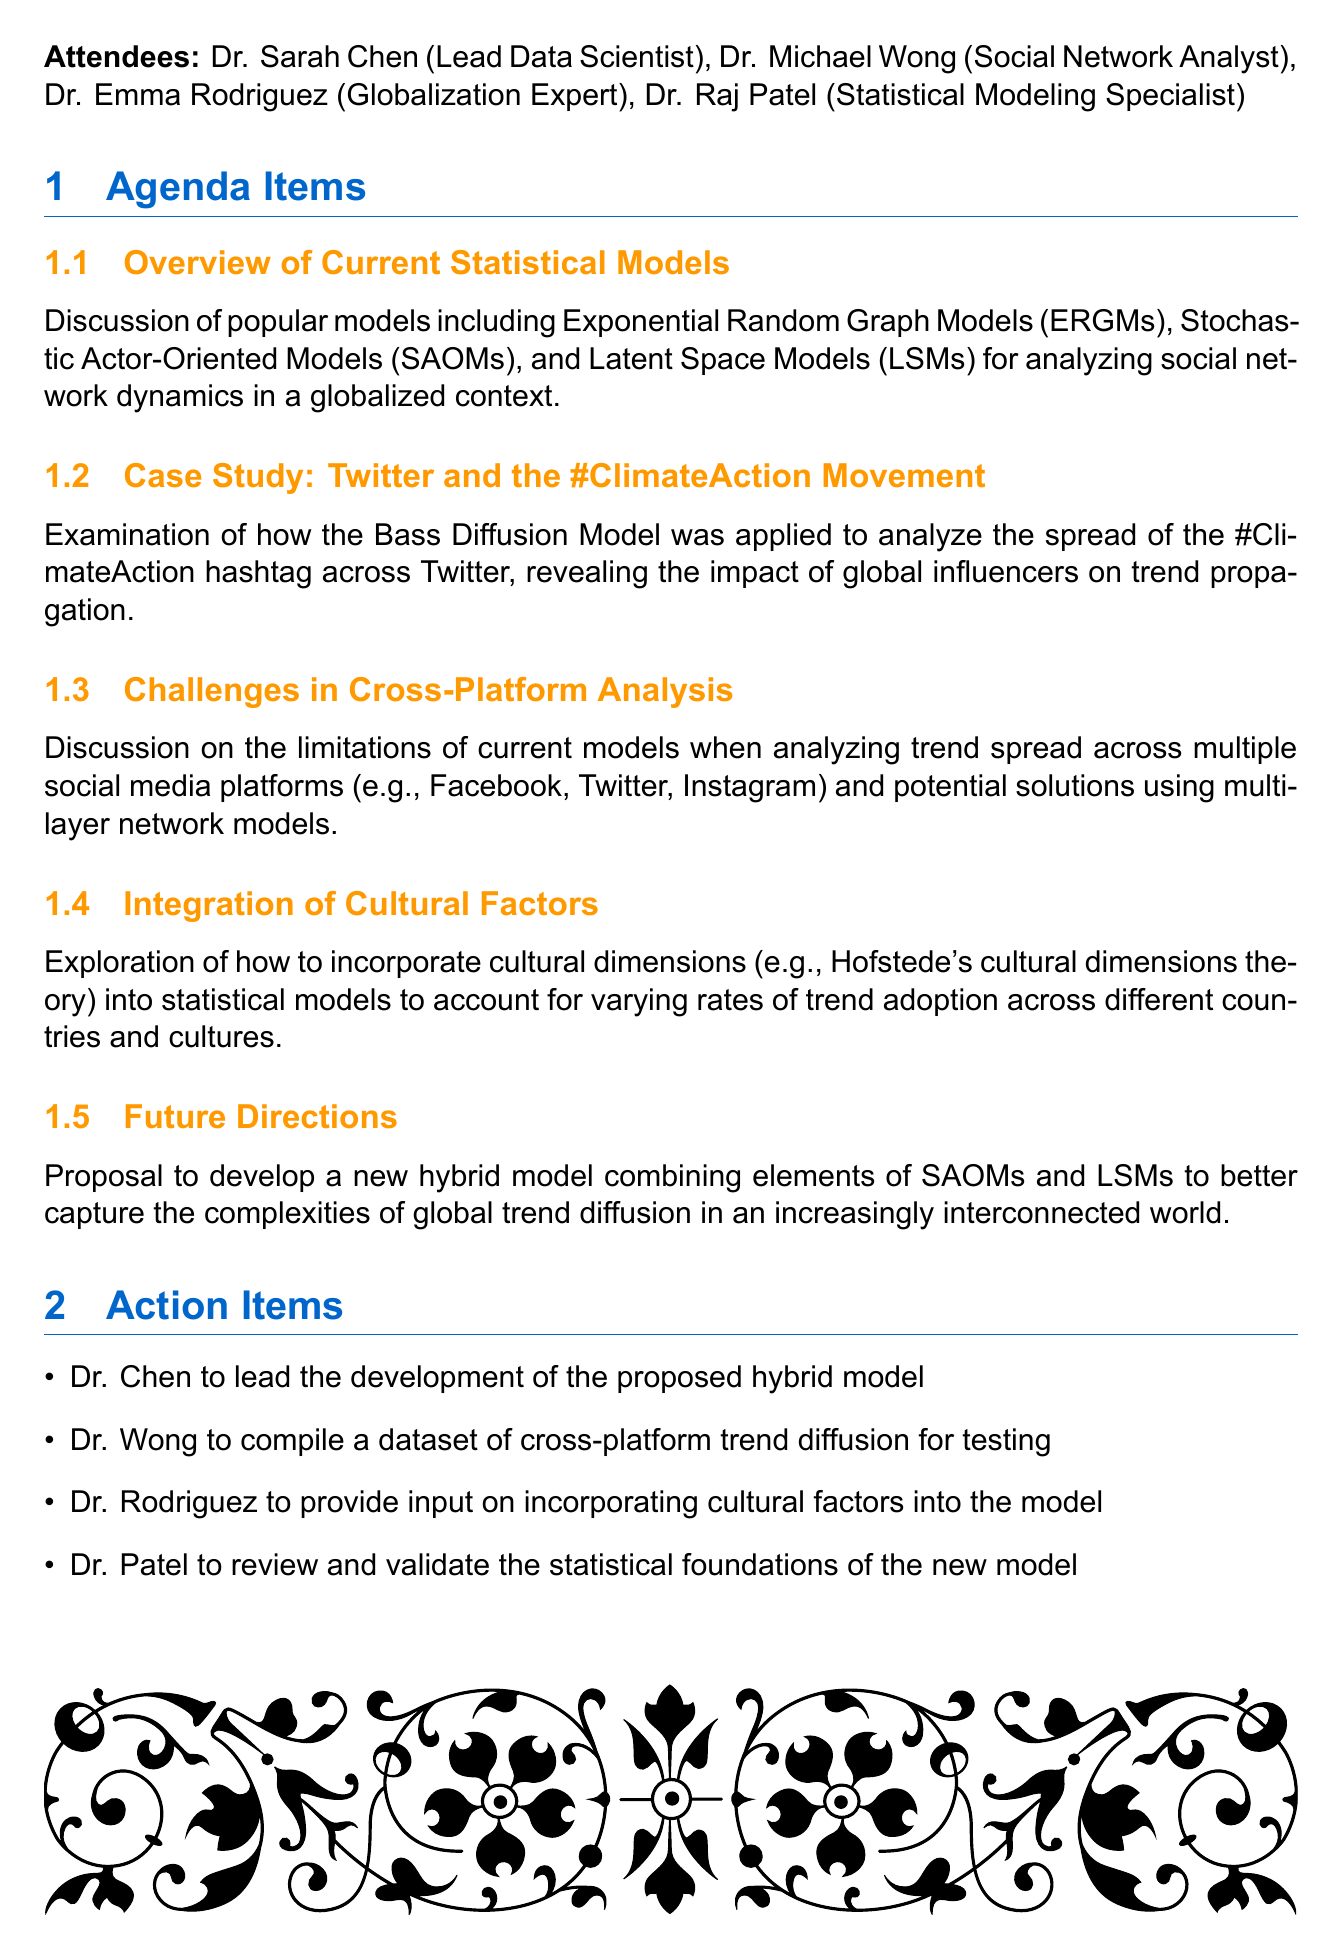What is the meeting title? The meeting title is prominently listed at the beginning of the document.
Answer: Review of Statistical Models for Analyzing Global Trend Spread on Social Media Who is the lead data scientist? The document lists attendees with their roles, identifying the lead data scientist.
Answer: Dr. Sarah Chen What date was the meeting held? The date of the meeting is mentioned at the start of the document.
Answer: May 15, 2023 What model was discussed in relation to the #ClimateAction hashtag? The specific model applied to analyze the spread of the hashtag is included in the case study section.
Answer: Bass Diffusion Model What are the proposed solutions for cross-platform analysis? The document discusses potential solutions within the Challenges in Cross-Platform Analysis agenda item.
Answer: Multi-layer network models Who is tasked with compiling a dataset for testing? The action items specify who will undertake each task after the meeting.
Answer: Dr. Wong What is the next meeting date? The date of the next meeting is provided at the end of the document.
Answer: June 1, 2023 Which cultural theory was mentioned for model integration? The section on cultural factors references a specific theory for incorporation into statistical models.
Answer: Hofstede's cultural dimensions theory How many attendees were present at the meeting? The attendees’ list provided allows counting the number of attendees.
Answer: Four 